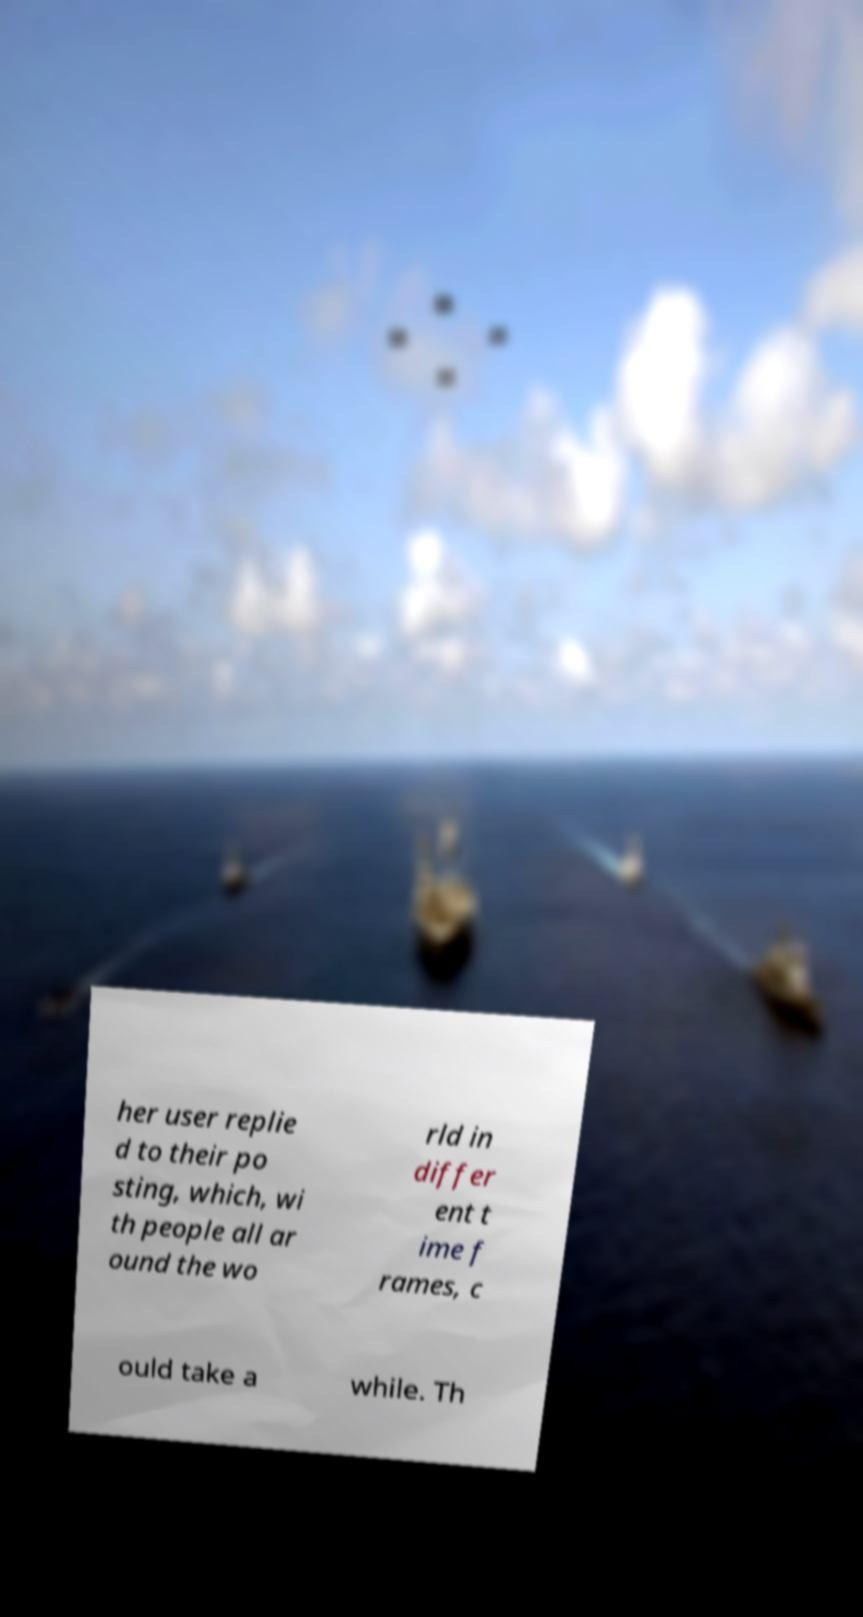For documentation purposes, I need the text within this image transcribed. Could you provide that? her user replie d to their po sting, which, wi th people all ar ound the wo rld in differ ent t ime f rames, c ould take a while. Th 